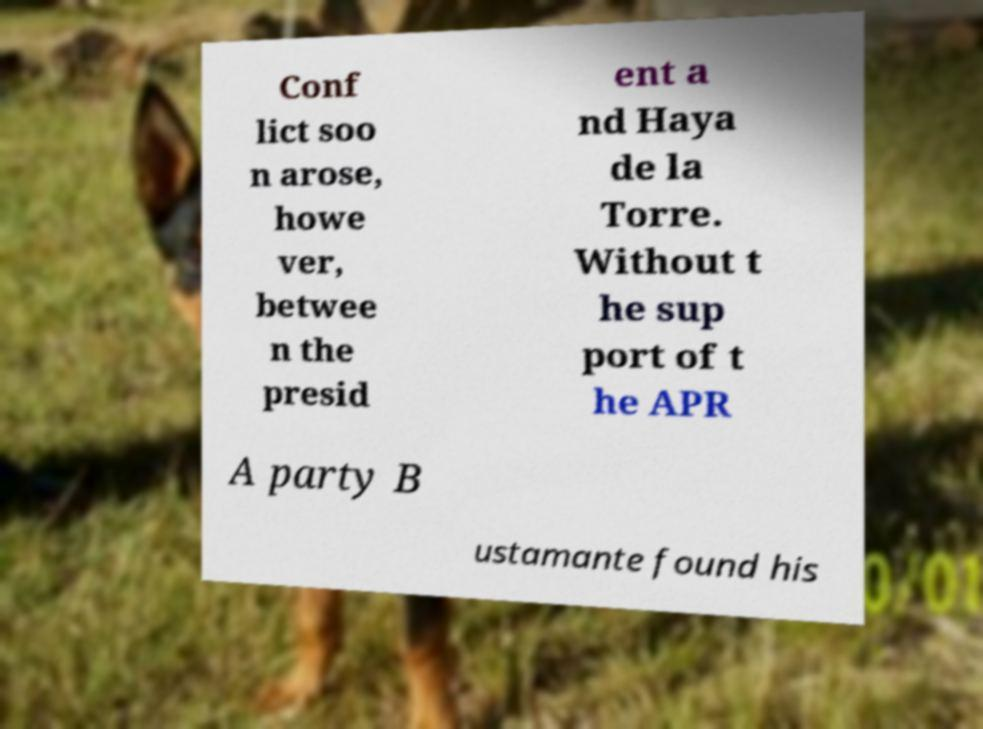Could you extract and type out the text from this image? Conf lict soo n arose, howe ver, betwee n the presid ent a nd Haya de la Torre. Without t he sup port of t he APR A party B ustamante found his 